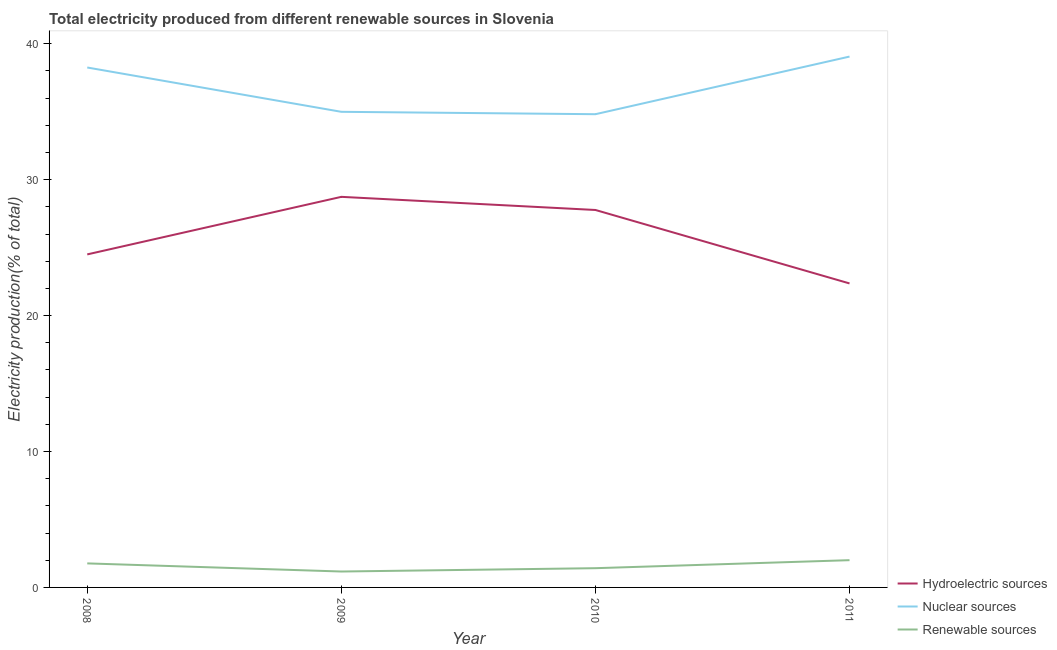What is the percentage of electricity produced by renewable sources in 2009?
Keep it short and to the point. 1.17. Across all years, what is the maximum percentage of electricity produced by renewable sources?
Ensure brevity in your answer.  2. Across all years, what is the minimum percentage of electricity produced by nuclear sources?
Offer a terse response. 34.82. In which year was the percentage of electricity produced by hydroelectric sources maximum?
Keep it short and to the point. 2009. What is the total percentage of electricity produced by hydroelectric sources in the graph?
Offer a very short reply. 103.37. What is the difference between the percentage of electricity produced by hydroelectric sources in 2010 and that in 2011?
Ensure brevity in your answer.  5.4. What is the difference between the percentage of electricity produced by renewable sources in 2010 and the percentage of electricity produced by nuclear sources in 2009?
Your response must be concise. -33.58. What is the average percentage of electricity produced by hydroelectric sources per year?
Offer a terse response. 25.84. In the year 2009, what is the difference between the percentage of electricity produced by renewable sources and percentage of electricity produced by nuclear sources?
Ensure brevity in your answer.  -33.82. In how many years, is the percentage of electricity produced by nuclear sources greater than 24 %?
Provide a succinct answer. 4. What is the ratio of the percentage of electricity produced by hydroelectric sources in 2008 to that in 2010?
Give a very brief answer. 0.88. Is the percentage of electricity produced by nuclear sources in 2010 less than that in 2011?
Ensure brevity in your answer.  Yes. Is the difference between the percentage of electricity produced by nuclear sources in 2010 and 2011 greater than the difference between the percentage of electricity produced by renewable sources in 2010 and 2011?
Make the answer very short. No. What is the difference between the highest and the second highest percentage of electricity produced by nuclear sources?
Provide a short and direct response. 0.8. What is the difference between the highest and the lowest percentage of electricity produced by renewable sources?
Your answer should be compact. 0.83. Is it the case that in every year, the sum of the percentage of electricity produced by hydroelectric sources and percentage of electricity produced by nuclear sources is greater than the percentage of electricity produced by renewable sources?
Offer a terse response. Yes. Does the percentage of electricity produced by nuclear sources monotonically increase over the years?
Keep it short and to the point. No. How many legend labels are there?
Keep it short and to the point. 3. How are the legend labels stacked?
Offer a very short reply. Vertical. What is the title of the graph?
Provide a succinct answer. Total electricity produced from different renewable sources in Slovenia. What is the label or title of the X-axis?
Ensure brevity in your answer.  Year. What is the Electricity production(% of total) of Hydroelectric sources in 2008?
Give a very brief answer. 24.5. What is the Electricity production(% of total) of Nuclear sources in 2008?
Your answer should be compact. 38.25. What is the Electricity production(% of total) in Renewable sources in 2008?
Keep it short and to the point. 1.77. What is the Electricity production(% of total) of Hydroelectric sources in 2009?
Give a very brief answer. 28.74. What is the Electricity production(% of total) of Nuclear sources in 2009?
Your answer should be very brief. 34.99. What is the Electricity production(% of total) in Renewable sources in 2009?
Make the answer very short. 1.17. What is the Electricity production(% of total) of Hydroelectric sources in 2010?
Provide a succinct answer. 27.77. What is the Electricity production(% of total) in Nuclear sources in 2010?
Keep it short and to the point. 34.82. What is the Electricity production(% of total) of Renewable sources in 2010?
Offer a very short reply. 1.42. What is the Electricity production(% of total) in Hydroelectric sources in 2011?
Give a very brief answer. 22.37. What is the Electricity production(% of total) of Nuclear sources in 2011?
Offer a very short reply. 39.06. What is the Electricity production(% of total) of Renewable sources in 2011?
Your answer should be very brief. 2. Across all years, what is the maximum Electricity production(% of total) of Hydroelectric sources?
Keep it short and to the point. 28.74. Across all years, what is the maximum Electricity production(% of total) of Nuclear sources?
Give a very brief answer. 39.06. Across all years, what is the maximum Electricity production(% of total) of Renewable sources?
Keep it short and to the point. 2. Across all years, what is the minimum Electricity production(% of total) in Hydroelectric sources?
Keep it short and to the point. 22.37. Across all years, what is the minimum Electricity production(% of total) in Nuclear sources?
Your response must be concise. 34.82. Across all years, what is the minimum Electricity production(% of total) in Renewable sources?
Your answer should be compact. 1.17. What is the total Electricity production(% of total) of Hydroelectric sources in the graph?
Provide a short and direct response. 103.37. What is the total Electricity production(% of total) in Nuclear sources in the graph?
Offer a very short reply. 147.12. What is the total Electricity production(% of total) of Renewable sources in the graph?
Provide a short and direct response. 6.36. What is the difference between the Electricity production(% of total) in Hydroelectric sources in 2008 and that in 2009?
Ensure brevity in your answer.  -4.23. What is the difference between the Electricity production(% of total) in Nuclear sources in 2008 and that in 2009?
Offer a terse response. 3.26. What is the difference between the Electricity production(% of total) of Renewable sources in 2008 and that in 2009?
Ensure brevity in your answer.  0.6. What is the difference between the Electricity production(% of total) in Hydroelectric sources in 2008 and that in 2010?
Offer a terse response. -3.27. What is the difference between the Electricity production(% of total) of Nuclear sources in 2008 and that in 2010?
Your answer should be very brief. 3.44. What is the difference between the Electricity production(% of total) in Renewable sources in 2008 and that in 2010?
Your response must be concise. 0.35. What is the difference between the Electricity production(% of total) in Hydroelectric sources in 2008 and that in 2011?
Make the answer very short. 2.14. What is the difference between the Electricity production(% of total) of Nuclear sources in 2008 and that in 2011?
Offer a terse response. -0.8. What is the difference between the Electricity production(% of total) of Renewable sources in 2008 and that in 2011?
Your answer should be very brief. -0.24. What is the difference between the Electricity production(% of total) in Hydroelectric sources in 2009 and that in 2010?
Ensure brevity in your answer.  0.97. What is the difference between the Electricity production(% of total) in Nuclear sources in 2009 and that in 2010?
Your response must be concise. 0.18. What is the difference between the Electricity production(% of total) of Renewable sources in 2009 and that in 2010?
Keep it short and to the point. -0.24. What is the difference between the Electricity production(% of total) in Hydroelectric sources in 2009 and that in 2011?
Provide a succinct answer. 6.37. What is the difference between the Electricity production(% of total) in Nuclear sources in 2009 and that in 2011?
Offer a very short reply. -4.06. What is the difference between the Electricity production(% of total) of Renewable sources in 2009 and that in 2011?
Your answer should be compact. -0.83. What is the difference between the Electricity production(% of total) of Hydroelectric sources in 2010 and that in 2011?
Your answer should be very brief. 5.4. What is the difference between the Electricity production(% of total) of Nuclear sources in 2010 and that in 2011?
Give a very brief answer. -4.24. What is the difference between the Electricity production(% of total) of Renewable sources in 2010 and that in 2011?
Provide a short and direct response. -0.59. What is the difference between the Electricity production(% of total) in Hydroelectric sources in 2008 and the Electricity production(% of total) in Nuclear sources in 2009?
Make the answer very short. -10.49. What is the difference between the Electricity production(% of total) of Hydroelectric sources in 2008 and the Electricity production(% of total) of Renewable sources in 2009?
Your answer should be compact. 23.33. What is the difference between the Electricity production(% of total) of Nuclear sources in 2008 and the Electricity production(% of total) of Renewable sources in 2009?
Give a very brief answer. 37.08. What is the difference between the Electricity production(% of total) in Hydroelectric sources in 2008 and the Electricity production(% of total) in Nuclear sources in 2010?
Make the answer very short. -10.32. What is the difference between the Electricity production(% of total) in Hydroelectric sources in 2008 and the Electricity production(% of total) in Renewable sources in 2010?
Offer a very short reply. 23.09. What is the difference between the Electricity production(% of total) of Nuclear sources in 2008 and the Electricity production(% of total) of Renewable sources in 2010?
Provide a short and direct response. 36.84. What is the difference between the Electricity production(% of total) in Hydroelectric sources in 2008 and the Electricity production(% of total) in Nuclear sources in 2011?
Your response must be concise. -14.55. What is the difference between the Electricity production(% of total) in Hydroelectric sources in 2008 and the Electricity production(% of total) in Renewable sources in 2011?
Keep it short and to the point. 22.5. What is the difference between the Electricity production(% of total) in Nuclear sources in 2008 and the Electricity production(% of total) in Renewable sources in 2011?
Give a very brief answer. 36.25. What is the difference between the Electricity production(% of total) of Hydroelectric sources in 2009 and the Electricity production(% of total) of Nuclear sources in 2010?
Your response must be concise. -6.08. What is the difference between the Electricity production(% of total) of Hydroelectric sources in 2009 and the Electricity production(% of total) of Renewable sources in 2010?
Your answer should be very brief. 27.32. What is the difference between the Electricity production(% of total) in Nuclear sources in 2009 and the Electricity production(% of total) in Renewable sources in 2010?
Provide a short and direct response. 33.58. What is the difference between the Electricity production(% of total) in Hydroelectric sources in 2009 and the Electricity production(% of total) in Nuclear sources in 2011?
Offer a terse response. -10.32. What is the difference between the Electricity production(% of total) in Hydroelectric sources in 2009 and the Electricity production(% of total) in Renewable sources in 2011?
Your answer should be compact. 26.73. What is the difference between the Electricity production(% of total) in Nuclear sources in 2009 and the Electricity production(% of total) in Renewable sources in 2011?
Offer a terse response. 32.99. What is the difference between the Electricity production(% of total) of Hydroelectric sources in 2010 and the Electricity production(% of total) of Nuclear sources in 2011?
Make the answer very short. -11.29. What is the difference between the Electricity production(% of total) of Hydroelectric sources in 2010 and the Electricity production(% of total) of Renewable sources in 2011?
Offer a very short reply. 25.76. What is the difference between the Electricity production(% of total) in Nuclear sources in 2010 and the Electricity production(% of total) in Renewable sources in 2011?
Ensure brevity in your answer.  32.81. What is the average Electricity production(% of total) in Hydroelectric sources per year?
Your answer should be very brief. 25.84. What is the average Electricity production(% of total) of Nuclear sources per year?
Your answer should be compact. 36.78. What is the average Electricity production(% of total) of Renewable sources per year?
Offer a very short reply. 1.59. In the year 2008, what is the difference between the Electricity production(% of total) of Hydroelectric sources and Electricity production(% of total) of Nuclear sources?
Your answer should be very brief. -13.75. In the year 2008, what is the difference between the Electricity production(% of total) of Hydroelectric sources and Electricity production(% of total) of Renewable sources?
Give a very brief answer. 22.73. In the year 2008, what is the difference between the Electricity production(% of total) in Nuclear sources and Electricity production(% of total) in Renewable sources?
Keep it short and to the point. 36.48. In the year 2009, what is the difference between the Electricity production(% of total) of Hydroelectric sources and Electricity production(% of total) of Nuclear sources?
Ensure brevity in your answer.  -6.26. In the year 2009, what is the difference between the Electricity production(% of total) of Hydroelectric sources and Electricity production(% of total) of Renewable sources?
Your response must be concise. 27.57. In the year 2009, what is the difference between the Electricity production(% of total) of Nuclear sources and Electricity production(% of total) of Renewable sources?
Offer a very short reply. 33.82. In the year 2010, what is the difference between the Electricity production(% of total) of Hydroelectric sources and Electricity production(% of total) of Nuclear sources?
Your answer should be compact. -7.05. In the year 2010, what is the difference between the Electricity production(% of total) of Hydroelectric sources and Electricity production(% of total) of Renewable sources?
Provide a succinct answer. 26.35. In the year 2010, what is the difference between the Electricity production(% of total) in Nuclear sources and Electricity production(% of total) in Renewable sources?
Provide a short and direct response. 33.4. In the year 2011, what is the difference between the Electricity production(% of total) of Hydroelectric sources and Electricity production(% of total) of Nuclear sources?
Make the answer very short. -16.69. In the year 2011, what is the difference between the Electricity production(% of total) in Hydroelectric sources and Electricity production(% of total) in Renewable sources?
Provide a short and direct response. 20.36. In the year 2011, what is the difference between the Electricity production(% of total) of Nuclear sources and Electricity production(% of total) of Renewable sources?
Offer a terse response. 37.05. What is the ratio of the Electricity production(% of total) of Hydroelectric sources in 2008 to that in 2009?
Make the answer very short. 0.85. What is the ratio of the Electricity production(% of total) of Nuclear sources in 2008 to that in 2009?
Give a very brief answer. 1.09. What is the ratio of the Electricity production(% of total) of Renewable sources in 2008 to that in 2009?
Provide a succinct answer. 1.51. What is the ratio of the Electricity production(% of total) in Hydroelectric sources in 2008 to that in 2010?
Make the answer very short. 0.88. What is the ratio of the Electricity production(% of total) of Nuclear sources in 2008 to that in 2010?
Offer a very short reply. 1.1. What is the ratio of the Electricity production(% of total) in Renewable sources in 2008 to that in 2010?
Your answer should be very brief. 1.25. What is the ratio of the Electricity production(% of total) in Hydroelectric sources in 2008 to that in 2011?
Keep it short and to the point. 1.1. What is the ratio of the Electricity production(% of total) in Nuclear sources in 2008 to that in 2011?
Your response must be concise. 0.98. What is the ratio of the Electricity production(% of total) in Renewable sources in 2008 to that in 2011?
Offer a very short reply. 0.88. What is the ratio of the Electricity production(% of total) of Hydroelectric sources in 2009 to that in 2010?
Your response must be concise. 1.03. What is the ratio of the Electricity production(% of total) of Nuclear sources in 2009 to that in 2010?
Your answer should be compact. 1. What is the ratio of the Electricity production(% of total) of Renewable sources in 2009 to that in 2010?
Give a very brief answer. 0.83. What is the ratio of the Electricity production(% of total) of Hydroelectric sources in 2009 to that in 2011?
Your answer should be compact. 1.28. What is the ratio of the Electricity production(% of total) in Nuclear sources in 2009 to that in 2011?
Provide a succinct answer. 0.9. What is the ratio of the Electricity production(% of total) in Renewable sources in 2009 to that in 2011?
Give a very brief answer. 0.58. What is the ratio of the Electricity production(% of total) in Hydroelectric sources in 2010 to that in 2011?
Provide a short and direct response. 1.24. What is the ratio of the Electricity production(% of total) of Nuclear sources in 2010 to that in 2011?
Your answer should be very brief. 0.89. What is the ratio of the Electricity production(% of total) in Renewable sources in 2010 to that in 2011?
Keep it short and to the point. 0.71. What is the difference between the highest and the second highest Electricity production(% of total) in Hydroelectric sources?
Give a very brief answer. 0.97. What is the difference between the highest and the second highest Electricity production(% of total) in Nuclear sources?
Ensure brevity in your answer.  0.8. What is the difference between the highest and the second highest Electricity production(% of total) in Renewable sources?
Offer a terse response. 0.24. What is the difference between the highest and the lowest Electricity production(% of total) of Hydroelectric sources?
Give a very brief answer. 6.37. What is the difference between the highest and the lowest Electricity production(% of total) in Nuclear sources?
Provide a succinct answer. 4.24. What is the difference between the highest and the lowest Electricity production(% of total) in Renewable sources?
Ensure brevity in your answer.  0.83. 